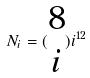<formula> <loc_0><loc_0><loc_500><loc_500>N _ { i } = ( \begin{matrix} 8 \\ i \end{matrix} ) i ^ { 1 2 }</formula> 